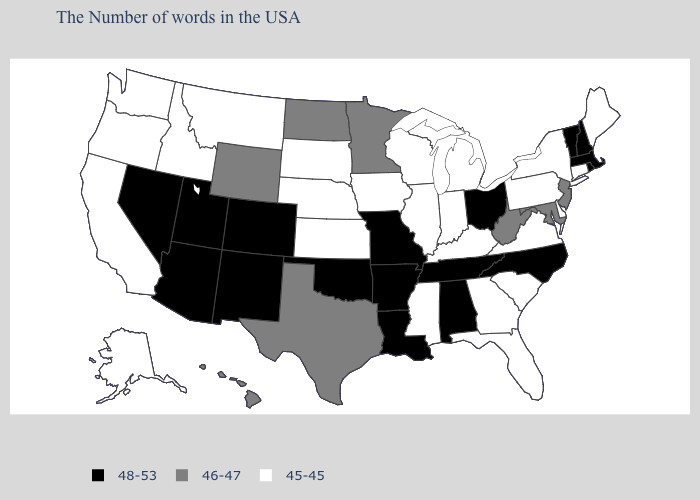What is the value of Connecticut?
Short answer required. 45-45. What is the lowest value in states that border California?
Write a very short answer. 45-45. Is the legend a continuous bar?
Keep it brief. No. Name the states that have a value in the range 46-47?
Short answer required. New Jersey, Maryland, West Virginia, Minnesota, Texas, North Dakota, Wyoming, Hawaii. Name the states that have a value in the range 48-53?
Answer briefly. Massachusetts, Rhode Island, New Hampshire, Vermont, North Carolina, Ohio, Alabama, Tennessee, Louisiana, Missouri, Arkansas, Oklahoma, Colorado, New Mexico, Utah, Arizona, Nevada. Among the states that border Wyoming , which have the highest value?
Short answer required. Colorado, Utah. Name the states that have a value in the range 46-47?
Quick response, please. New Jersey, Maryland, West Virginia, Minnesota, Texas, North Dakota, Wyoming, Hawaii. Name the states that have a value in the range 48-53?
Keep it brief. Massachusetts, Rhode Island, New Hampshire, Vermont, North Carolina, Ohio, Alabama, Tennessee, Louisiana, Missouri, Arkansas, Oklahoma, Colorado, New Mexico, Utah, Arizona, Nevada. What is the lowest value in the West?
Write a very short answer. 45-45. What is the value of Hawaii?
Keep it brief. 46-47. Name the states that have a value in the range 45-45?
Short answer required. Maine, Connecticut, New York, Delaware, Pennsylvania, Virginia, South Carolina, Florida, Georgia, Michigan, Kentucky, Indiana, Wisconsin, Illinois, Mississippi, Iowa, Kansas, Nebraska, South Dakota, Montana, Idaho, California, Washington, Oregon, Alaska. What is the value of Colorado?
Concise answer only. 48-53. What is the value of Texas?
Be succinct. 46-47. What is the value of South Carolina?
Write a very short answer. 45-45. Which states have the lowest value in the USA?
Answer briefly. Maine, Connecticut, New York, Delaware, Pennsylvania, Virginia, South Carolina, Florida, Georgia, Michigan, Kentucky, Indiana, Wisconsin, Illinois, Mississippi, Iowa, Kansas, Nebraska, South Dakota, Montana, Idaho, California, Washington, Oregon, Alaska. 